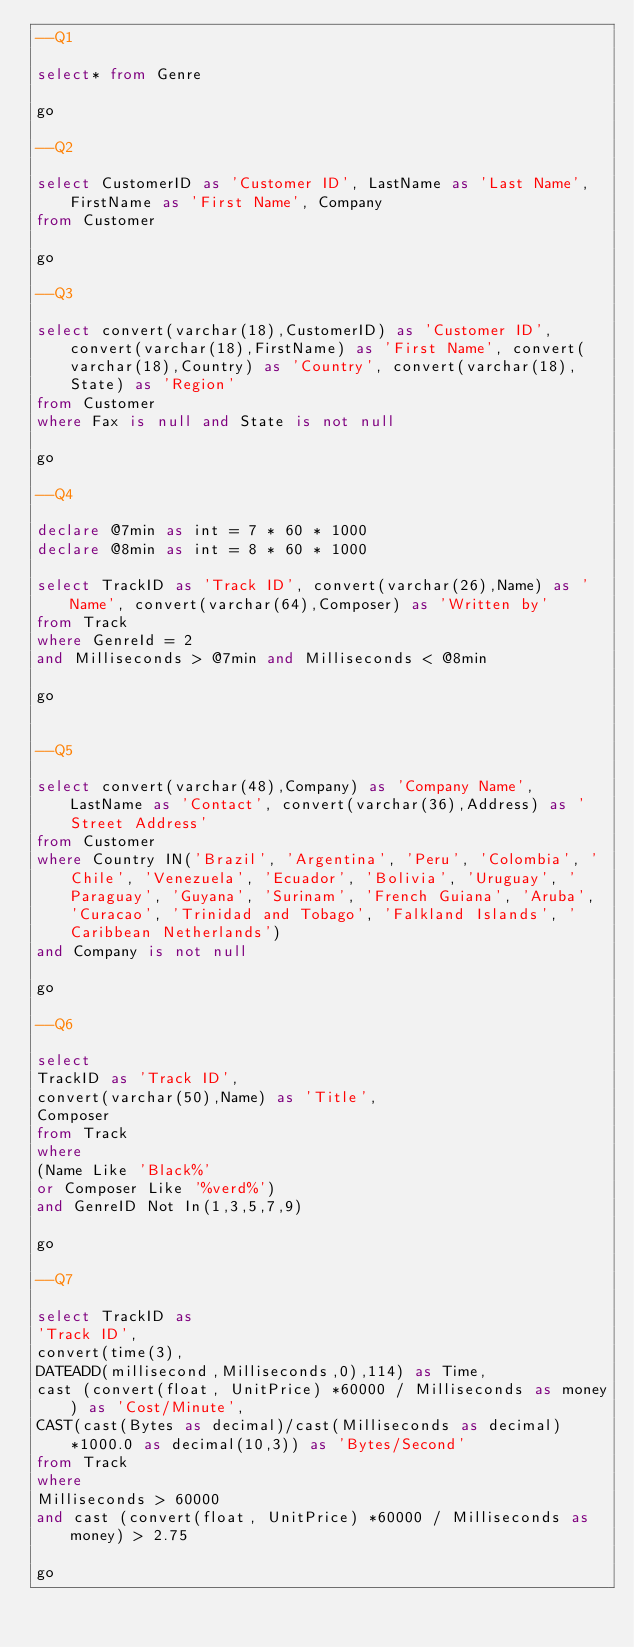Convert code to text. <code><loc_0><loc_0><loc_500><loc_500><_SQL_>--Q1

select* from Genre

go

--Q2

select CustomerID as 'Customer ID', LastName as 'Last Name', FirstName as 'First Name', Company 
from Customer

go

--Q3

select convert(varchar(18),CustomerID) as 'Customer ID', convert(varchar(18),FirstName) as 'First Name', convert(varchar(18),Country) as 'Country', convert(varchar(18),State) as 'Region'
from Customer
where Fax is null and State is not null

go

--Q4

declare @7min as int = 7 * 60 * 1000
declare @8min as int = 8 * 60 * 1000

select TrackID as 'Track ID', convert(varchar(26),Name) as 'Name', convert(varchar(64),Composer) as 'Written by' 
from Track
where GenreId = 2
and Milliseconds > @7min and Milliseconds < @8min

go


--Q5

select convert(varchar(48),Company) as 'Company Name', LastName as 'Contact', convert(varchar(36),Address) as 'Street Address'
from Customer
where Country IN('Brazil', 'Argentina', 'Peru', 'Colombia', 'Chile', 'Venezuela', 'Ecuador', 'Bolivia', 'Uruguay', 'Paraguay', 'Guyana', 'Surinam', 'French Guiana', 'Aruba', 'Curacao', 'Trinidad and Tobago', 'Falkland Islands', 'Caribbean Netherlands')
and Company is not null

go

--Q6

select 
TrackID as 'Track ID', 
convert(varchar(50),Name) as 'Title', 
Composer
from Track
where 
(Name Like 'Black%' 
or Composer Like '%verd%') 
and GenreID Not In(1,3,5,7,9)

go

--Q7

select TrackID as 
'Track ID', 
convert(time(3),
DATEADD(millisecond,Milliseconds,0),114) as Time, 
cast (convert(float, UnitPrice) *60000 / Milliseconds as money) as 'Cost/Minute',
CAST(cast(Bytes as decimal)/cast(Milliseconds as decimal)*1000.0 as decimal(10,3)) as 'Bytes/Second'
from Track
where
Milliseconds > 60000
and cast (convert(float, UnitPrice) *60000 / Milliseconds as money) > 2.75

go

 </code> 